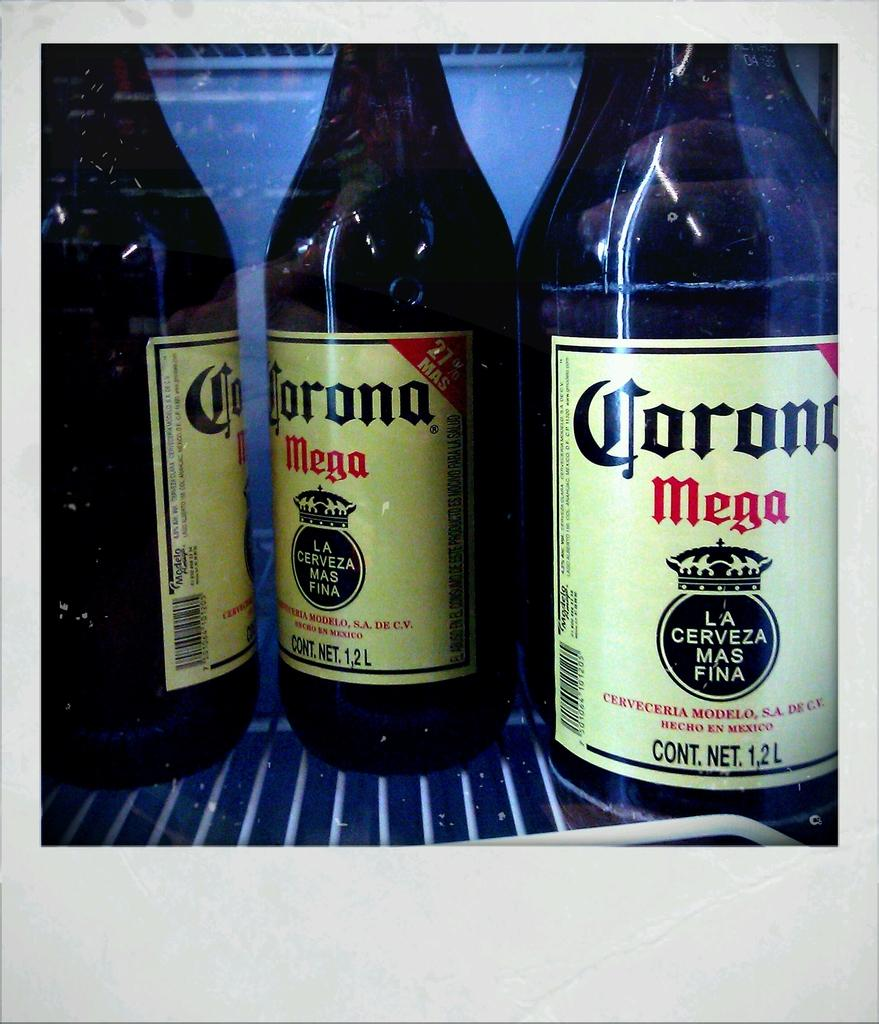<image>
Share a concise interpretation of the image provided. Bottles of alcohol with one saying MEGA in red. 